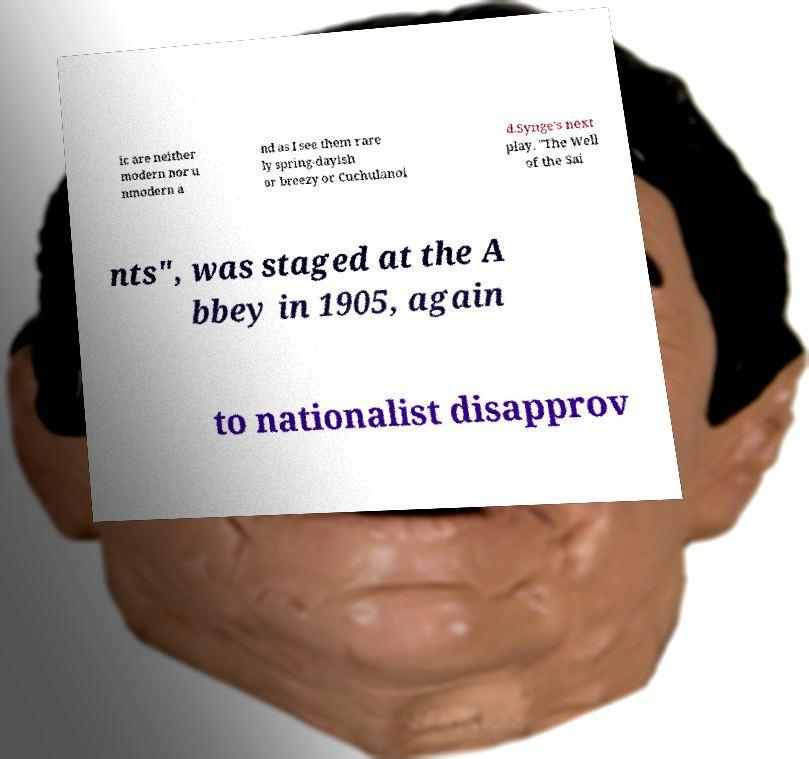Can you accurately transcribe the text from the provided image for me? ic are neither modern nor u nmodern a nd as I see them rare ly spring-dayish or breezy or Cuchulanoi d.Synge's next play, "The Well of the Sai nts", was staged at the A bbey in 1905, again to nationalist disapprov 